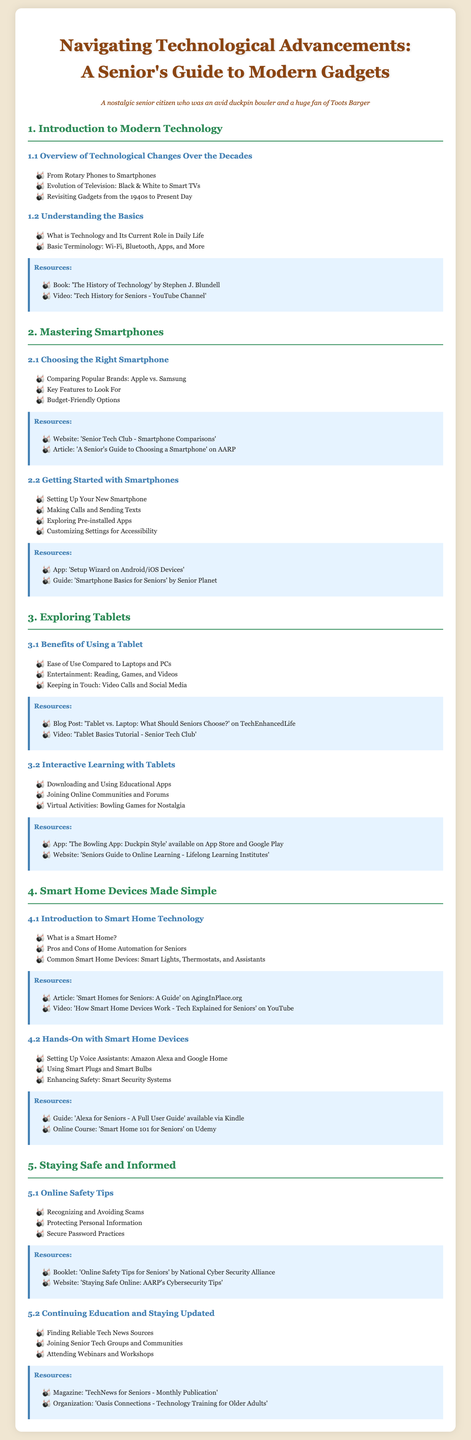What is the title of the syllabus? The title is presented at the top of the document, summarizing the content about technology for seniors.
Answer: Navigating Technological Advancements: A Senior's Guide to Modern Gadgets What section covers smartphones? The section specifically focused on smartphones is identified by the main heading related to smartphones.
Answer: Mastering Smartphones Which brand is compared in the smartphone section? The document explicitly mentions the two brands that are compared in terms of their features and popularity.
Answer: Apple vs. Samsung What type of educational resources are suggested for tablet learning? The resources mentioned provide guidance on using tablets, particularly focusing on educational apps and activities.
Answer: Educational Apps What is the first topic under Online Safety Tips? This is the first element listed that helps seniors stay safe while using technology, particularly regarding scams.
Answer: Recognizing and Avoiding Scams What is the purpose of joining senior tech groups? The document explains the benefits of engaging with communities and groups specifically for seniors.
Answer: Staying Updated How many main sections are in the syllabus? By counting the main headings listed in the document, we identify the total sections covered.
Answer: Five What kind of devices are included in smart home technology? The document lists the common devices that are part of a smart home system, specifically.
Answer: Smart Lights, Thermostats, and Assistants 